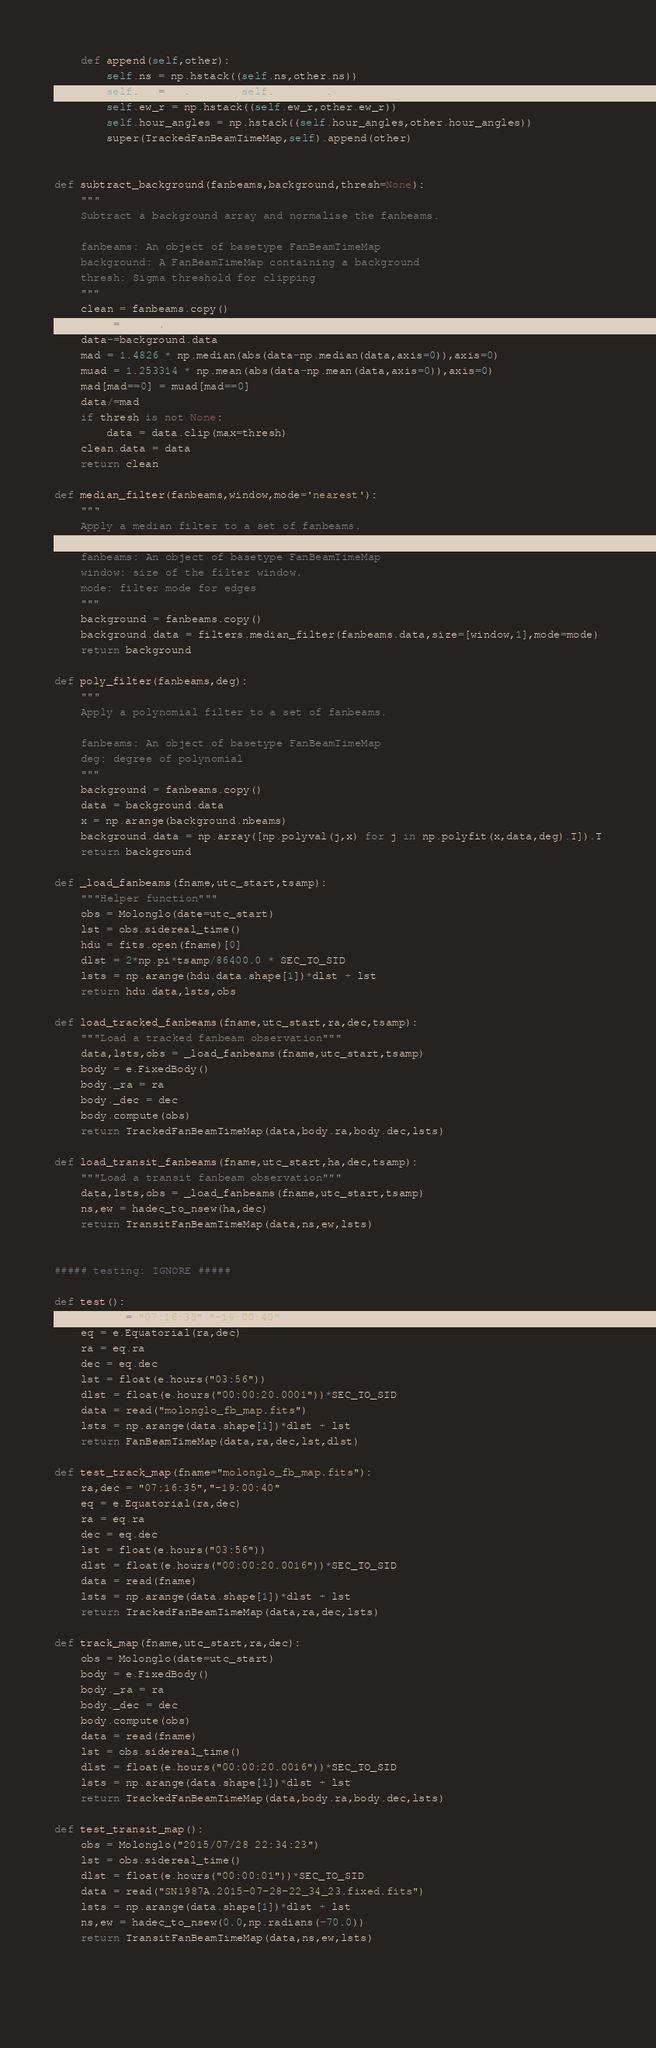Convert code to text. <code><loc_0><loc_0><loc_500><loc_500><_Python_>
    def append(self,other):
        self.ns = np.hstack((self.ns,other.ns))
        self.ew = np.hstack((self.ew,other.ew))
        self.ew_r = np.hstack((self.ew_r,other.ew_r))
        self.hour_angles = np.hstack((self.hour_angles,other.hour_angles))
        super(TrackedFanBeamTimeMap,self).append(other)


def subtract_background(fanbeams,background,thresh=None):
    """
    Subtract a background array and normalise the fanbeams.

    fanbeams: An object of basetype FanBeamTimeMap
    background: A FanBeamTimeMap containing a background 
    thresh: Sigma threshold for clipping
    """
    clean = fanbeams.copy()
    data = clean.data
    data-=background.data
    mad = 1.4826 * np.median(abs(data-np.median(data,axis=0)),axis=0)
    muad = 1.253314 * np.mean(abs(data-np.mean(data,axis=0)),axis=0)
    mad[mad==0] = muad[mad==0]
    data/=mad
    if thresh is not None:
        data = data.clip(max=thresh)
    clean.data = data
    return clean

def median_filter(fanbeams,window,mode='nearest'):
    """
    Apply a median filter to a set of fanbeams.

    fanbeams: An object of basetype FanBeamTimeMap
    window: size of the filter window.
    mode: filter mode for edges
    """
    background = fanbeams.copy()
    background.data = filters.median_filter(fanbeams.data,size=[window,1],mode=mode)
    return background

def poly_filter(fanbeams,deg):
    """
    Apply a polynomial filter to a set of fanbeams.

    fanbeams: An object of basetype FanBeamTimeMap
    deg: degree of polynomial
    """
    background = fanbeams.copy()
    data = background.data
    x = np.arange(background.nbeams)
    background.data = np.array([np.polyval(j,x) for j in np.polyfit(x,data,deg).T]).T
    return background

def _load_fanbeams(fname,utc_start,tsamp):
    """Helper function"""
    obs = Molonglo(date=utc_start)
    lst = obs.sidereal_time()
    hdu = fits.open(fname)[0]
    dlst = 2*np.pi*tsamp/86400.0 * SEC_TO_SID
    lsts = np.arange(hdu.data.shape[1])*dlst + lst
    return hdu.data,lsts,obs

def load_tracked_fanbeams(fname,utc_start,ra,dec,tsamp):
    """Load a tracked fanbeam observation"""
    data,lsts,obs = _load_fanbeams(fname,utc_start,tsamp)
    body = e.FixedBody()
    body._ra = ra
    body._dec = dec
    body.compute(obs)
    return TrackedFanBeamTimeMap(data,body.ra,body.dec,lsts)

def load_transit_fanbeams(fname,utc_start,ha,dec,tsamp):
    """Load a transit fanbeam observation"""
    data,lsts,obs = _load_fanbeams(fname,utc_start,tsamp)
    ns,ew = hadec_to_nsew(ha,dec)
    return TransitFanBeamTimeMap(data,ns,ew,lsts)


##### testing: IGNORE #####

def test():
    ra,dec = "07:16:35","-19:00:40"
    eq = e.Equatorial(ra,dec)
    ra = eq.ra
    dec = eq.dec
    lst = float(e.hours("03:56"))
    dlst = float(e.hours("00:00:20.0001"))*SEC_TO_SID
    data = read("molonglo_fb_map.fits")
    lsts = np.arange(data.shape[1])*dlst + lst
    return FanBeamTimeMap(data,ra,dec,lst,dlst)

def test_track_map(fname="molonglo_fb_map.fits"):
    ra,dec = "07:16:35","-19:00:40"
    eq = e.Equatorial(ra,dec)
    ra = eq.ra
    dec = eq.dec
    lst = float(e.hours("03:56"))
    dlst = float(e.hours("00:00:20.0016"))*SEC_TO_SID
    data = read(fname)
    lsts = np.arange(data.shape[1])*dlst + lst
    return TrackedFanBeamTimeMap(data,ra,dec,lsts)

def track_map(fname,utc_start,ra,dec):
    obs = Molonglo(date=utc_start)
    body = e.FixedBody()
    body._ra = ra
    body._dec = dec
    body.compute(obs)
    data = read(fname)
    lst = obs.sidereal_time()
    dlst = float(e.hours("00:00:20.0016"))*SEC_TO_SID
    lsts = np.arange(data.shape[1])*dlst + lst
    return TrackedFanBeamTimeMap(data,body.ra,body.dec,lsts)

def test_transit_map():
    obs = Molonglo("2015/07/28 22:34:23")
    lst = obs.sidereal_time()
    dlst = float(e.hours("00:00:01"))*SEC_TO_SID
    data = read("SN1987A.2015-07-28-22_34_23.fixed.fits")
    lsts = np.arange(data.shape[1])*dlst + lst
    ns,ew = hadec_to_nsew(0.0,np.radians(-70.0))
    return TransitFanBeamTimeMap(data,ns,ew,lsts)
            
    
    
</code> 